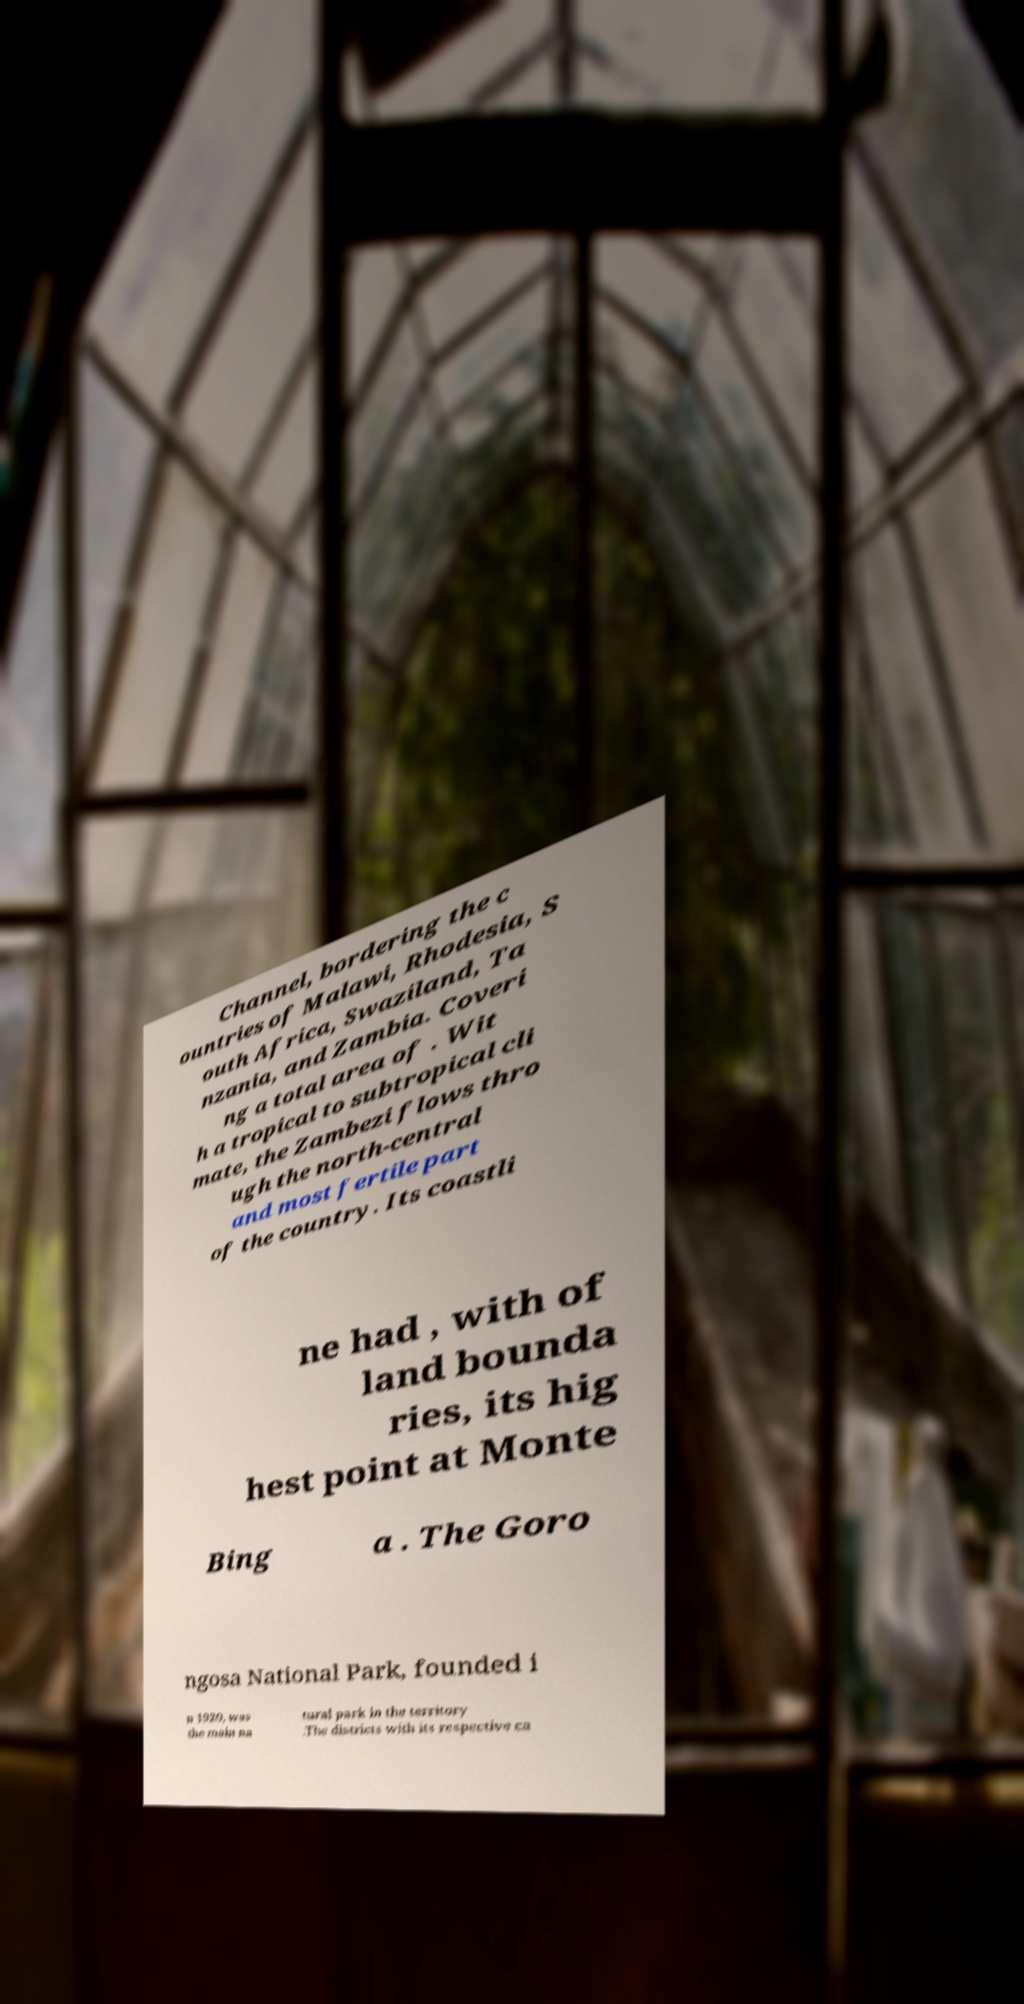What messages or text are displayed in this image? I need them in a readable, typed format. Channel, bordering the c ountries of Malawi, Rhodesia, S outh Africa, Swaziland, Ta nzania, and Zambia. Coveri ng a total area of . Wit h a tropical to subtropical cli mate, the Zambezi flows thro ugh the north-central and most fertile part of the country. Its coastli ne had , with of land bounda ries, its hig hest point at Monte Bing a . The Goro ngosa National Park, founded i n 1920, was the main na tural park in the territory .The districts with its respective ca 